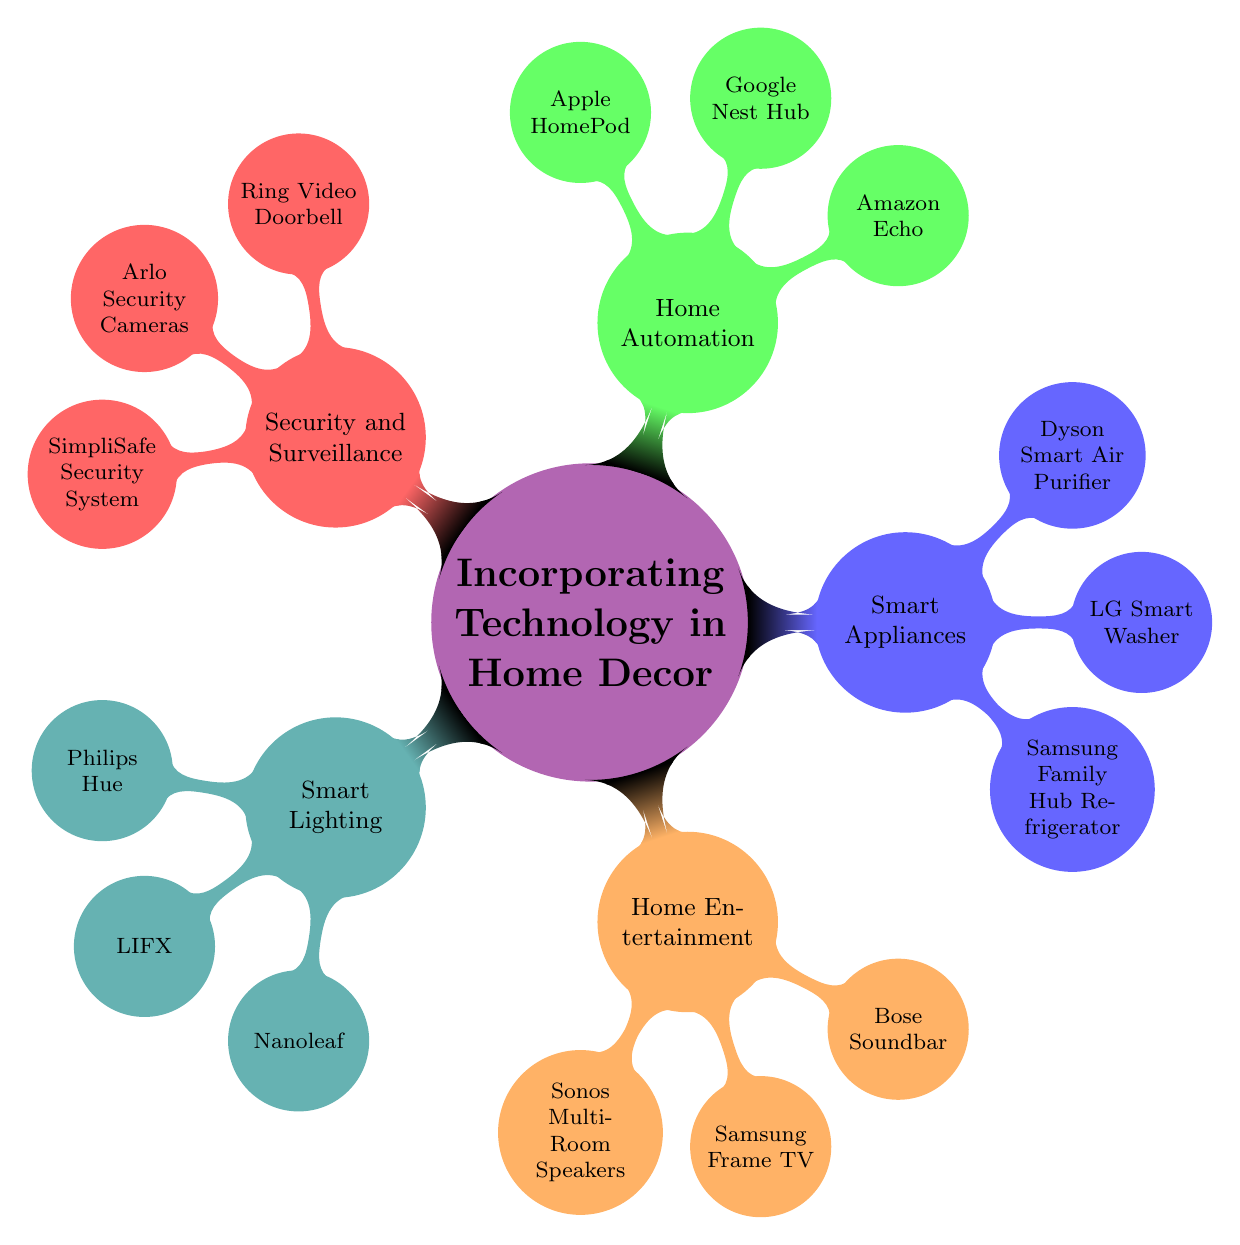What is the main topic of the mind map? The central node of the mind map clearly states the main topic as "Incorporating Technology in Home Decor," which encompasses all other nodes and subtopics.
Answer: Incorporating Technology in Home Decor How many subtopics are under "Incorporating Technology in Home Decor"? Counting the child nodes directly under the main topic, there are five subtopics: Smart Lighting, Home Entertainment, Smart Appliances, Home Automation, and Security and Surveillance.
Answer: 5 Which subtopic includes "Samsung Frame TV"? By inspecting the nodes within the subtopic branch labeled "Home Entertainment," "Samsung Frame TV" is explicitly listed as one of its nodes.
Answer: Home Entertainment What technology is associated with air purification? Referring to the subtopic "Smart Appliances," the node that refers to air purification technology is the "Dyson Smart Air Purifier."
Answer: Dyson Smart Air Purifier List one node related to home automation. The subtopic "Home Automation" has three associated nodes: "Amazon Echo," "Google Nest Hub," and "Apple HomePod." Any can be mentioned as a valid answer.
Answer: Amazon Echo How many nodes are there under "Smart Lighting"? Under the "Smart Lighting" subtopic, there are three nodes mentioned: "Philips Hue," "LIFX," and "Nanoleaf." Thus, the total count is three.
Answer: 3 Which subtopic contains devices for security and surveillance? The "Security and Surveillance" subtopic specifically includes three nodes: "Ring Video Doorbell," "Arlo Security Cameras," and "SimpliSafe Security System," indicating the theme of security devices.
Answer: Security and Surveillance What is the relationship between "Amazon Echo" and "Home Automation"? "Amazon Echo" is a node that directly belongs to the "Home Automation" subtopic, indicating that it is a smart device that fits within the scope of home automation technology.
Answer: Amazon Echo is a part of Home Automation Which subtopic has the node "LG Smart Washer"? The node "LG Smart Washer" can be found under the subtopic "Smart Appliances," indicating its category as a technologically enhanced home appliance.
Answer: Smart Appliances Name a product listed under "Smart Appliances." The subtopic "Smart Appliances" includes three nodes: "Samsung Family Hub Refrigerator," "LG Smart Washer," and "Dyson Smart Air Purifier." Any one of them can be answered as an example of a product.
Answer: Samsung Family Hub Refrigerator 